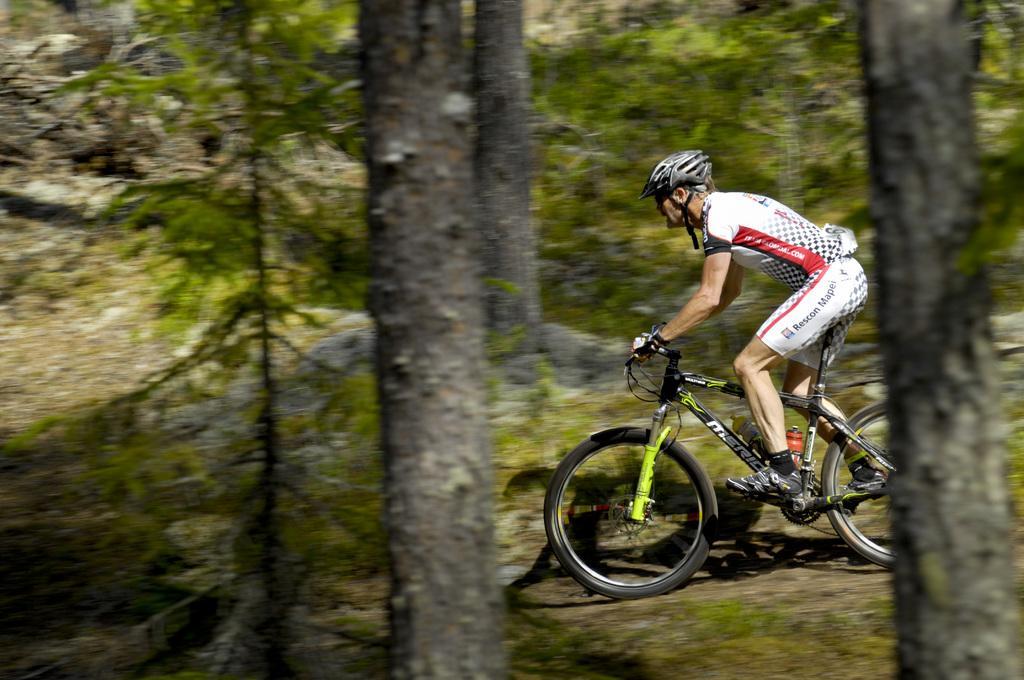Describe this image in one or two sentences. In this picture we can see a man wore a helmet, gloves, shoes and riding a bicycle on the ground and in the background we can see trees. 